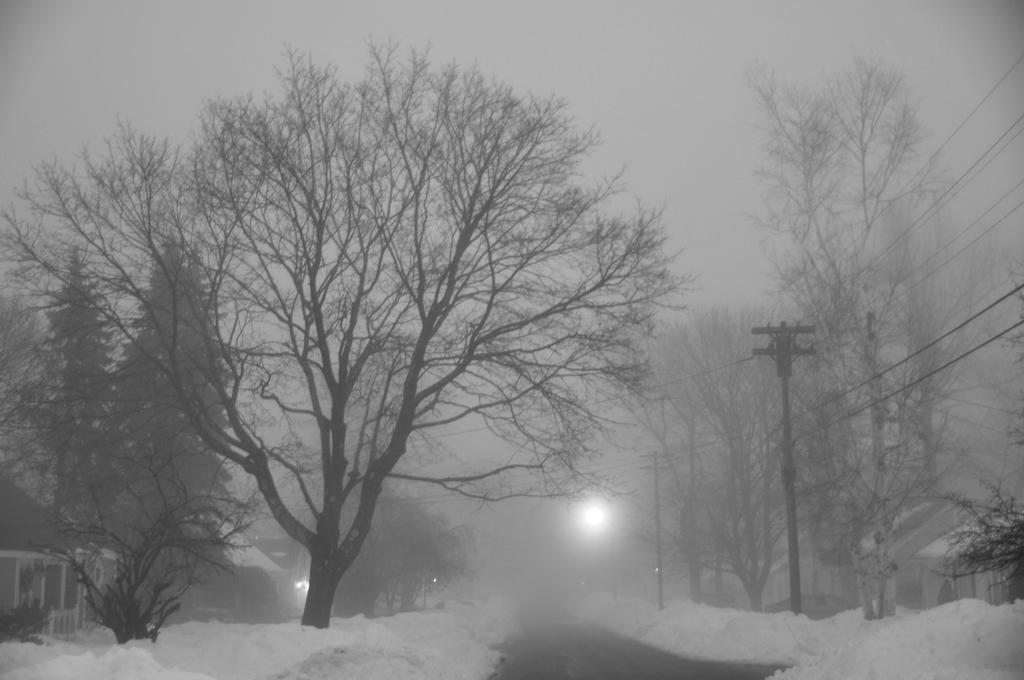What is the main feature in the middle of the image? There is a path in the middle of the image. What can be seen on both sides of the path? There are trees and buildings on both sides of the path. What is present on the right side of the image? Electric poles with cables are present on the right side of the image. What is the condition of the ground in the image? There is snow covering the ground in the image. How many pickles are hanging from the trees on the left side of the image? There are no pickles present in the image; the trees are not bearing any fruits or vegetables. 